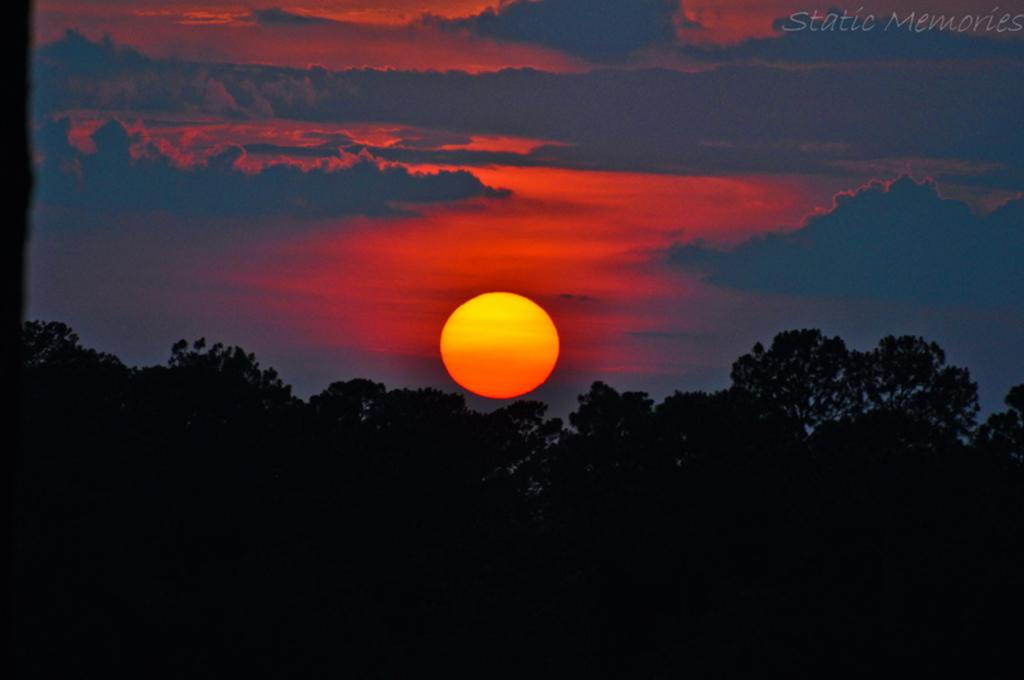What type of vegetation can be seen in the image? There are trees in the image. What part of the natural environment is visible in the image? The sky is visible in the image. Can you describe the celestial body present in the sky? The sun is present in the sky. What else can be seen in the sky besides the sun? Clouds are visible in the sky. How many spiders are crawling on the stage in the image? There are no spiders or stage present in the image. Can you describe the swimming activity taking place in the image? There is no swimming activity depicted in the image; it features trees, sky, sun, and clouds. 